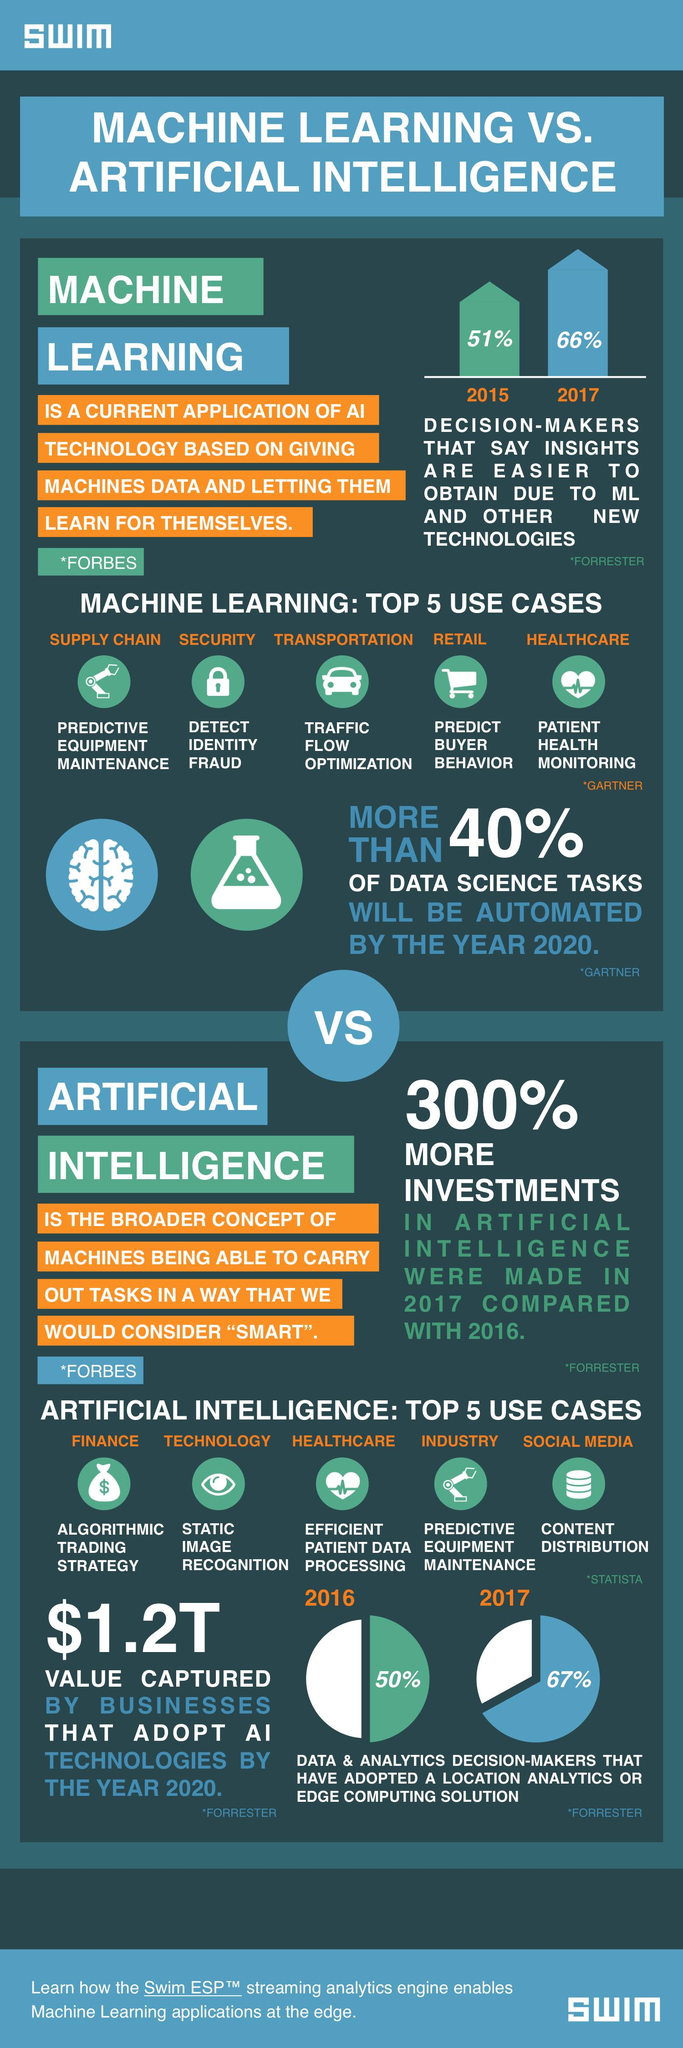Highlight a few significant elements in this photo. Machine learning (ML) is used in retail to predict buyer behavior. The top three use cases of AI are finance, technology, and healthcare. The top three use cases in machine learning are supply chain, security, and transportation. AI is commonly used in social media for content distribution. By 2020, businesses that utilize AI technologies are projected to gain approximately 1.2 trillion dollars. 